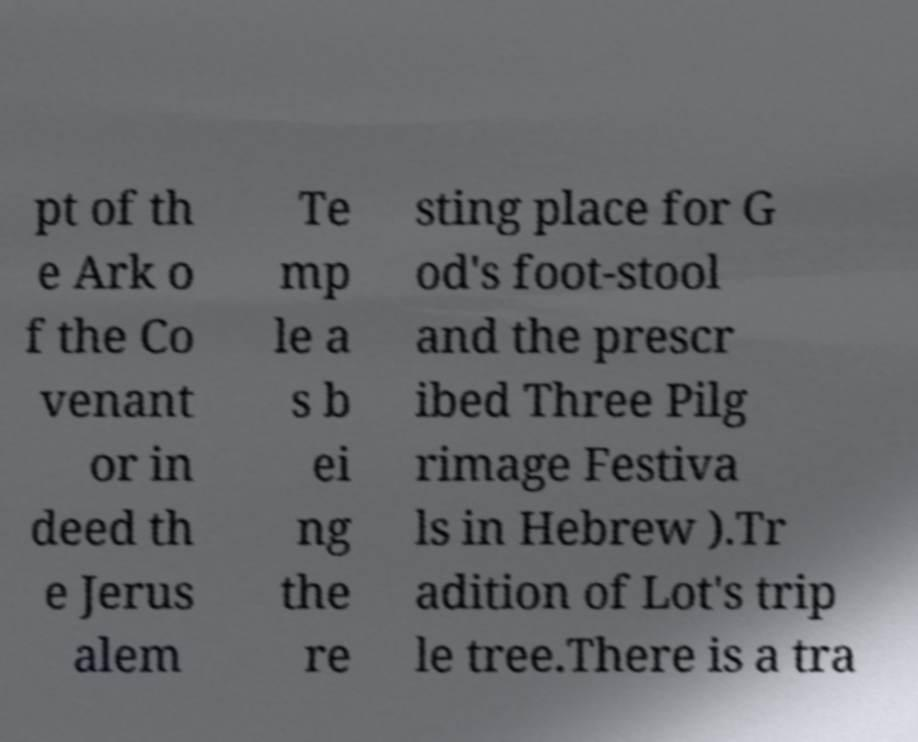Please identify and transcribe the text found in this image. pt of th e Ark o f the Co venant or in deed th e Jerus alem Te mp le a s b ei ng the re sting place for G od's foot-stool and the prescr ibed Three Pilg rimage Festiva ls in Hebrew ).Tr adition of Lot's trip le tree.There is a tra 